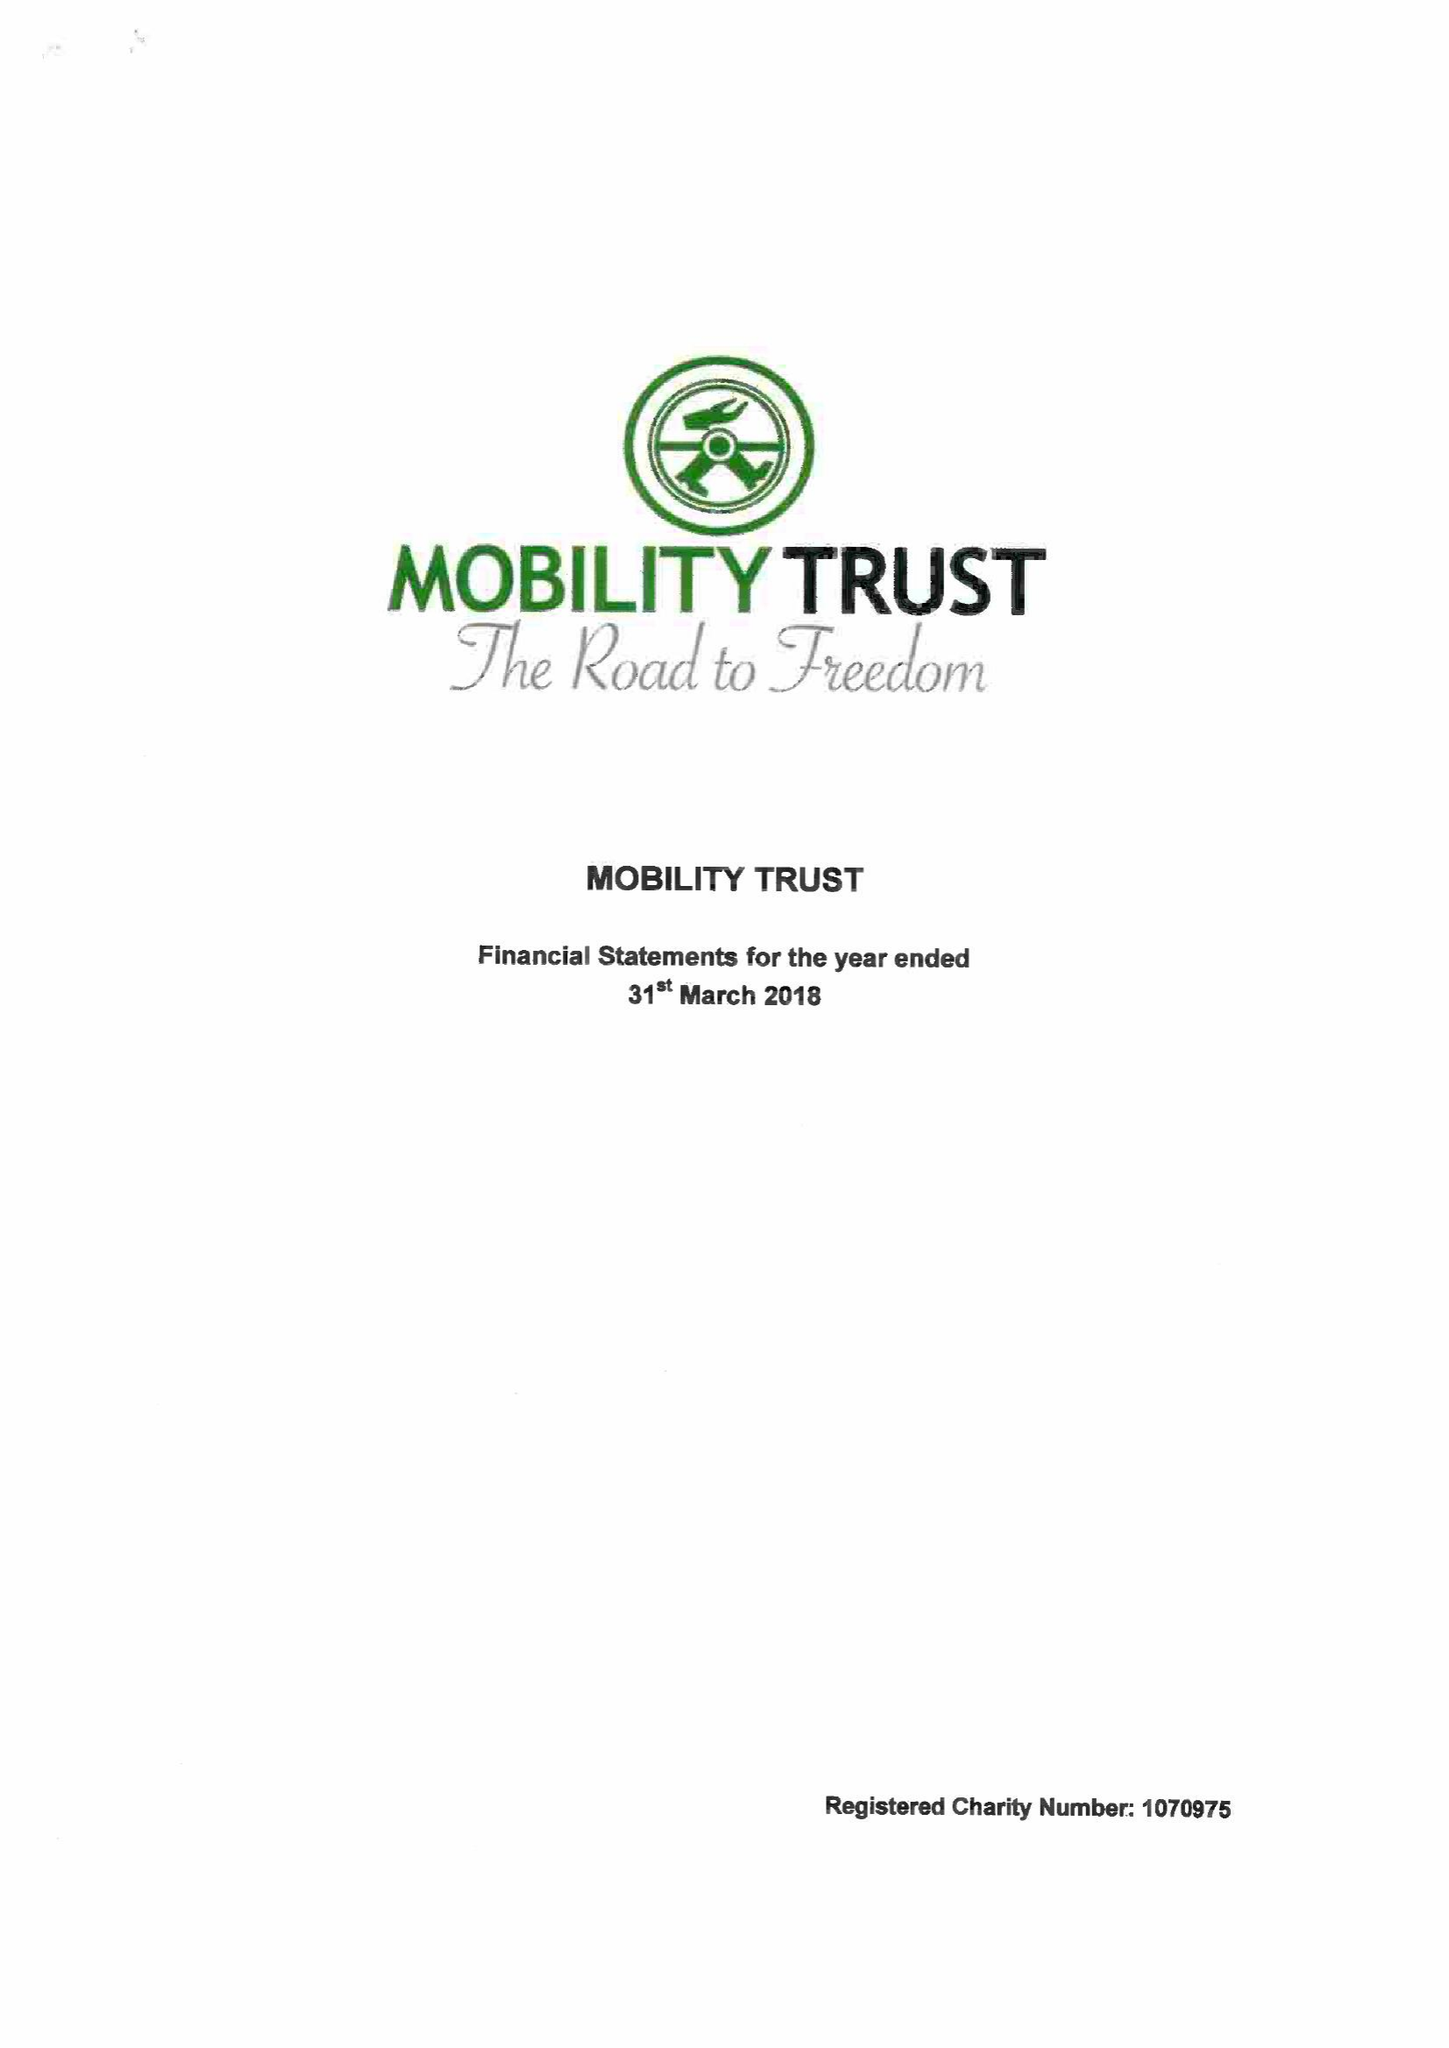What is the value for the report_date?
Answer the question using a single word or phrase. 2018-03-31 